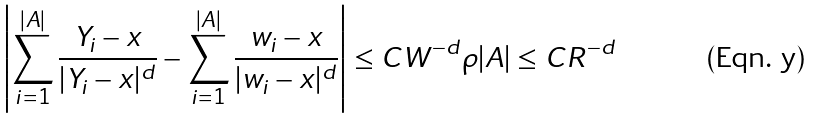Convert formula to latex. <formula><loc_0><loc_0><loc_500><loc_500>\left | \sum _ { i = 1 } ^ { | A | } \frac { Y _ { i } - x } { | Y _ { i } - x | ^ { d } } - \sum _ { i = 1 } ^ { | A | } \frac { w _ { i } - x } { | w _ { i } - x | ^ { d } } \right | \leq C W ^ { - d } \rho | A | \leq C R ^ { - d }</formula> 